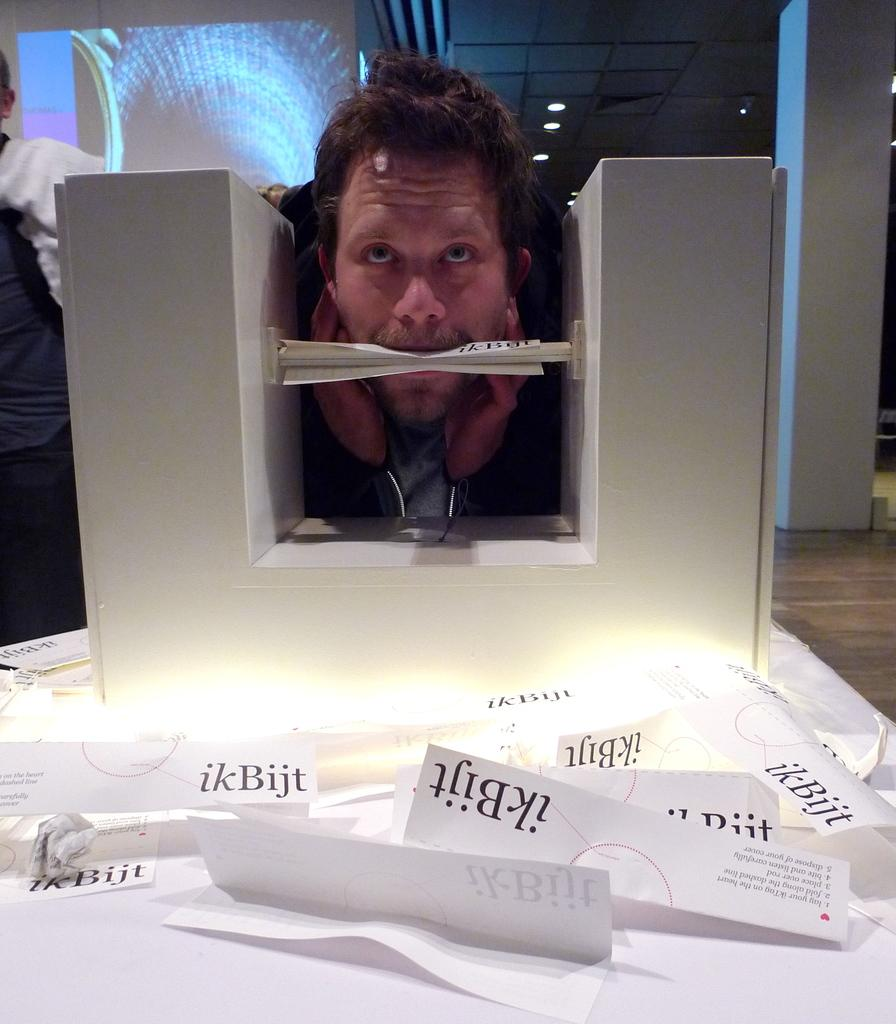<image>
Give a short and clear explanation of the subsequent image. A man is biting down on a piece of paper that has ikBijt printed on it. 